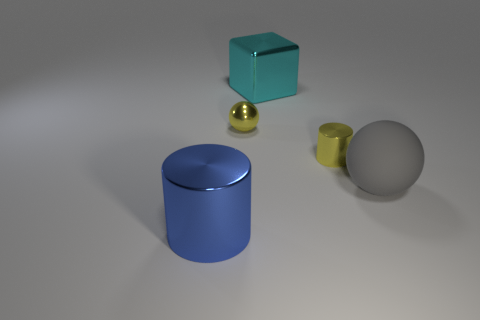Add 3 brown shiny cylinders. How many objects exist? 8 Subtract all cylinders. How many objects are left? 3 Add 4 large gray rubber blocks. How many large gray rubber blocks exist? 4 Subtract 0 green spheres. How many objects are left? 5 Subtract all large rubber cylinders. Subtract all blue shiny things. How many objects are left? 4 Add 1 cyan things. How many cyan things are left? 2 